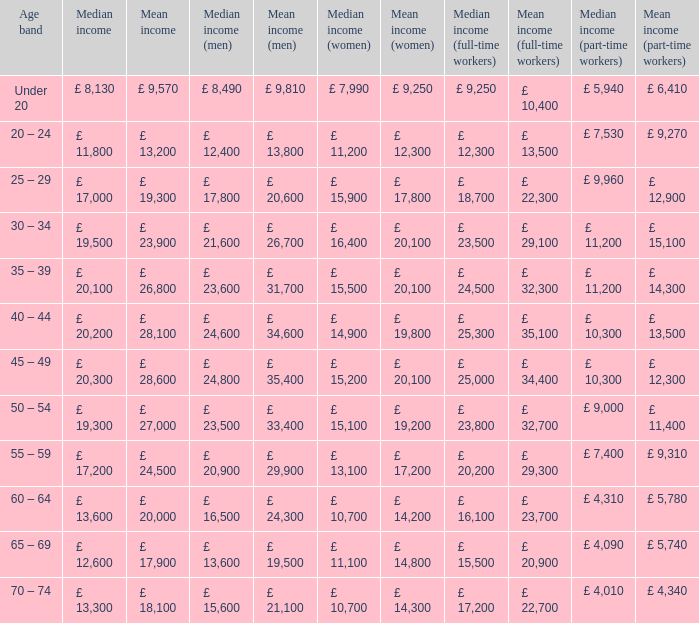Name the median income for age band being under 20 £ 8,130. 